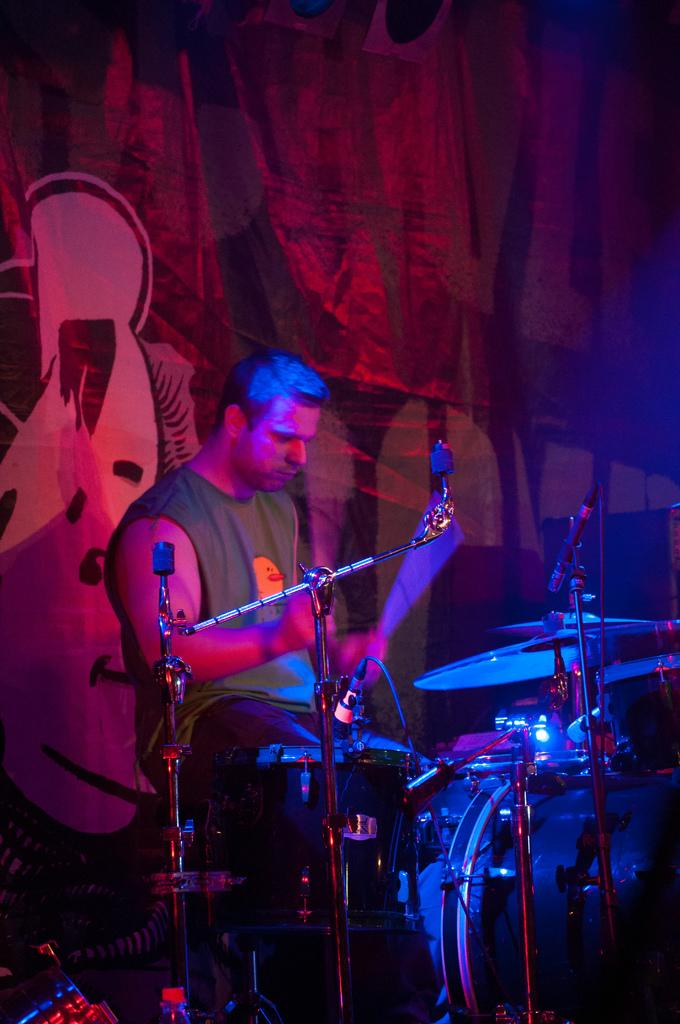What is the man in the image doing? The man is playing a musical instrument in the image. What objects are present in the image that are related to sound amplification? There are microphones with stands in the image. What can be seen in the background of the image? There is a banner in the background of the image. Can you see any badges or receipts in the image? No, there are no badges or receipts present in the image. Are there any bells visible in the image? No, there are no bells visible in the image. 